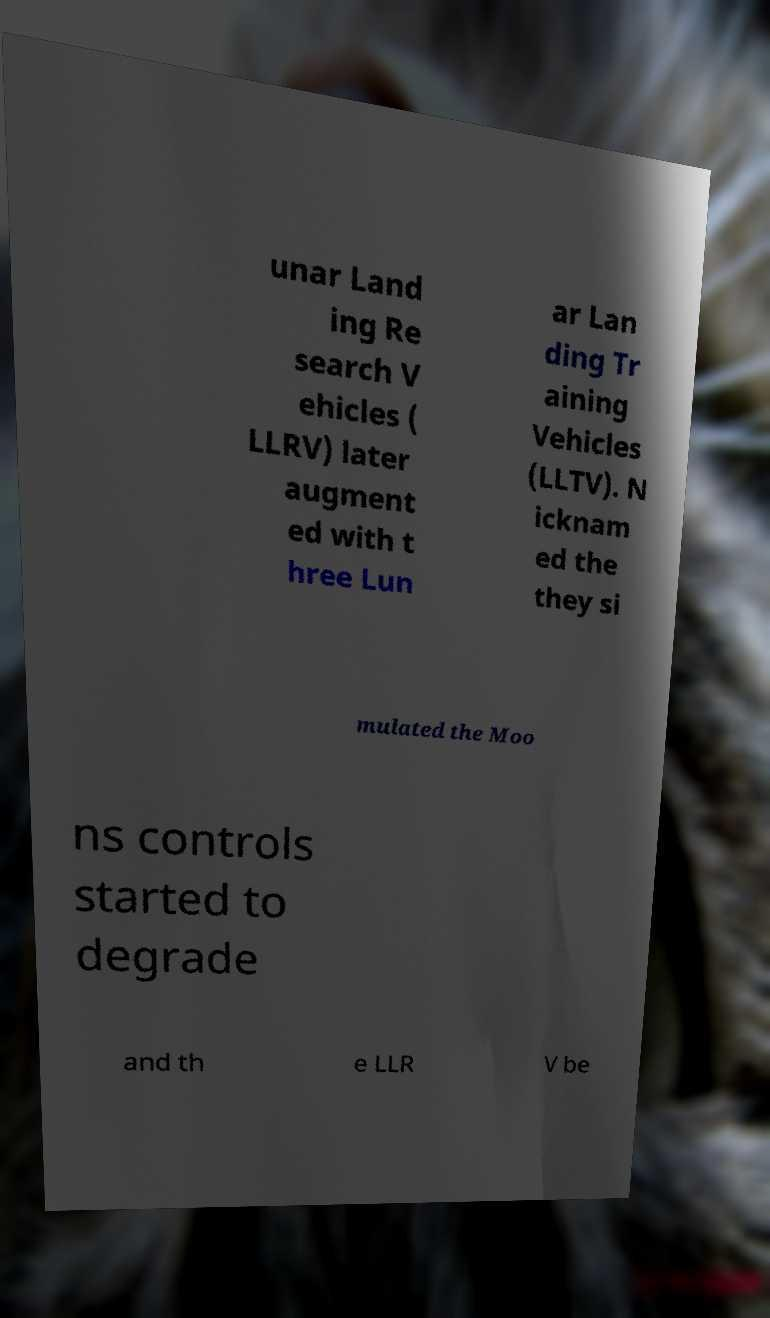I need the written content from this picture converted into text. Can you do that? unar Land ing Re search V ehicles ( LLRV) later augment ed with t hree Lun ar Lan ding Tr aining Vehicles (LLTV). N icknam ed the they si mulated the Moo ns controls started to degrade and th e LLR V be 